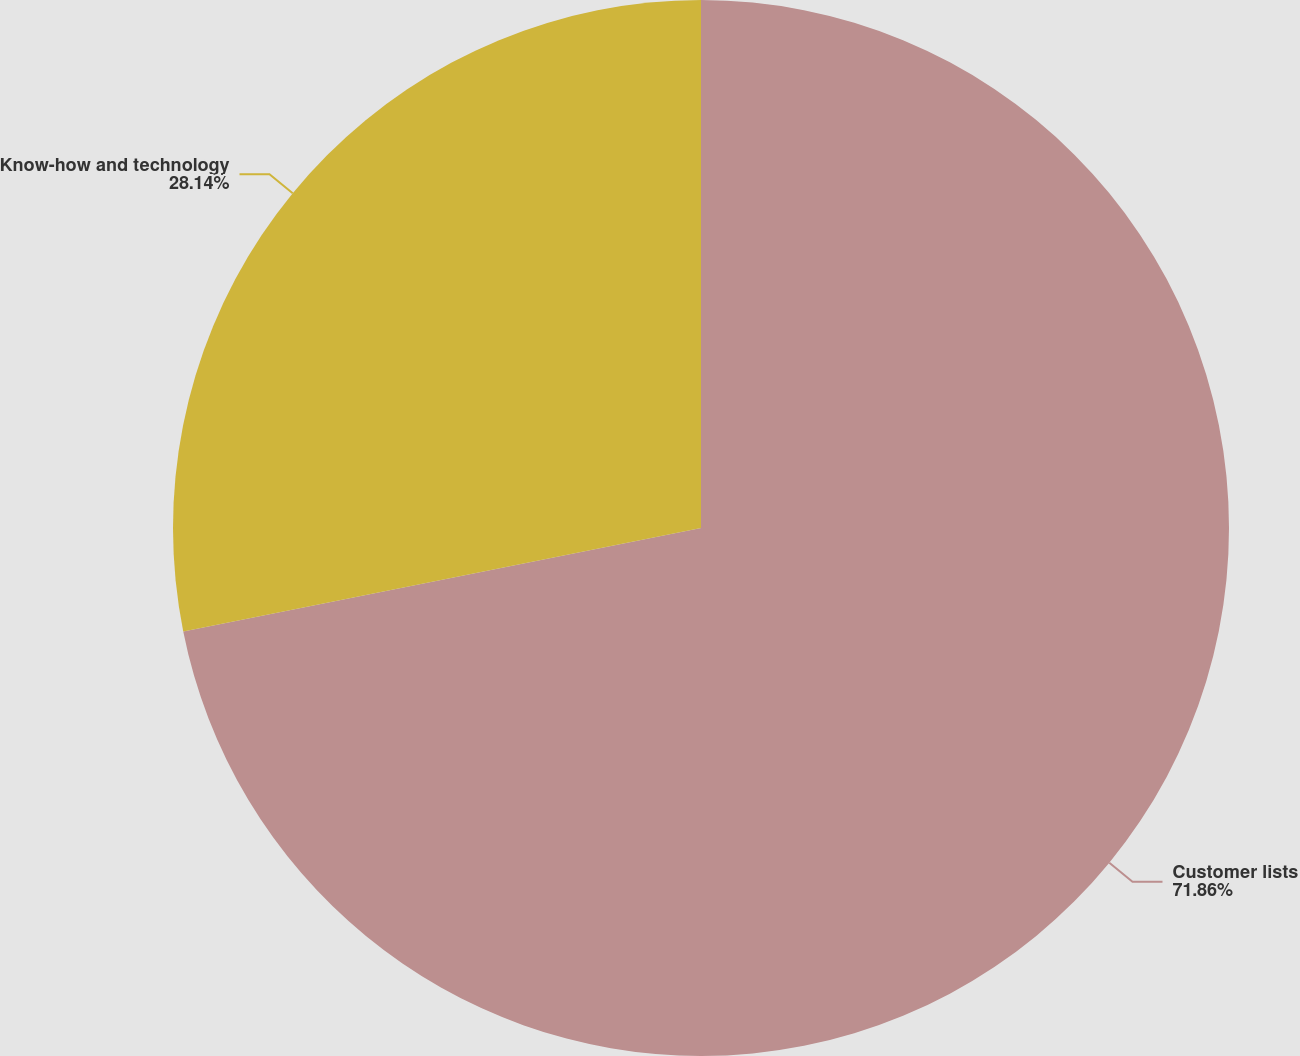Convert chart to OTSL. <chart><loc_0><loc_0><loc_500><loc_500><pie_chart><fcel>Customer lists<fcel>Know-how and technology<nl><fcel>71.86%<fcel>28.14%<nl></chart> 